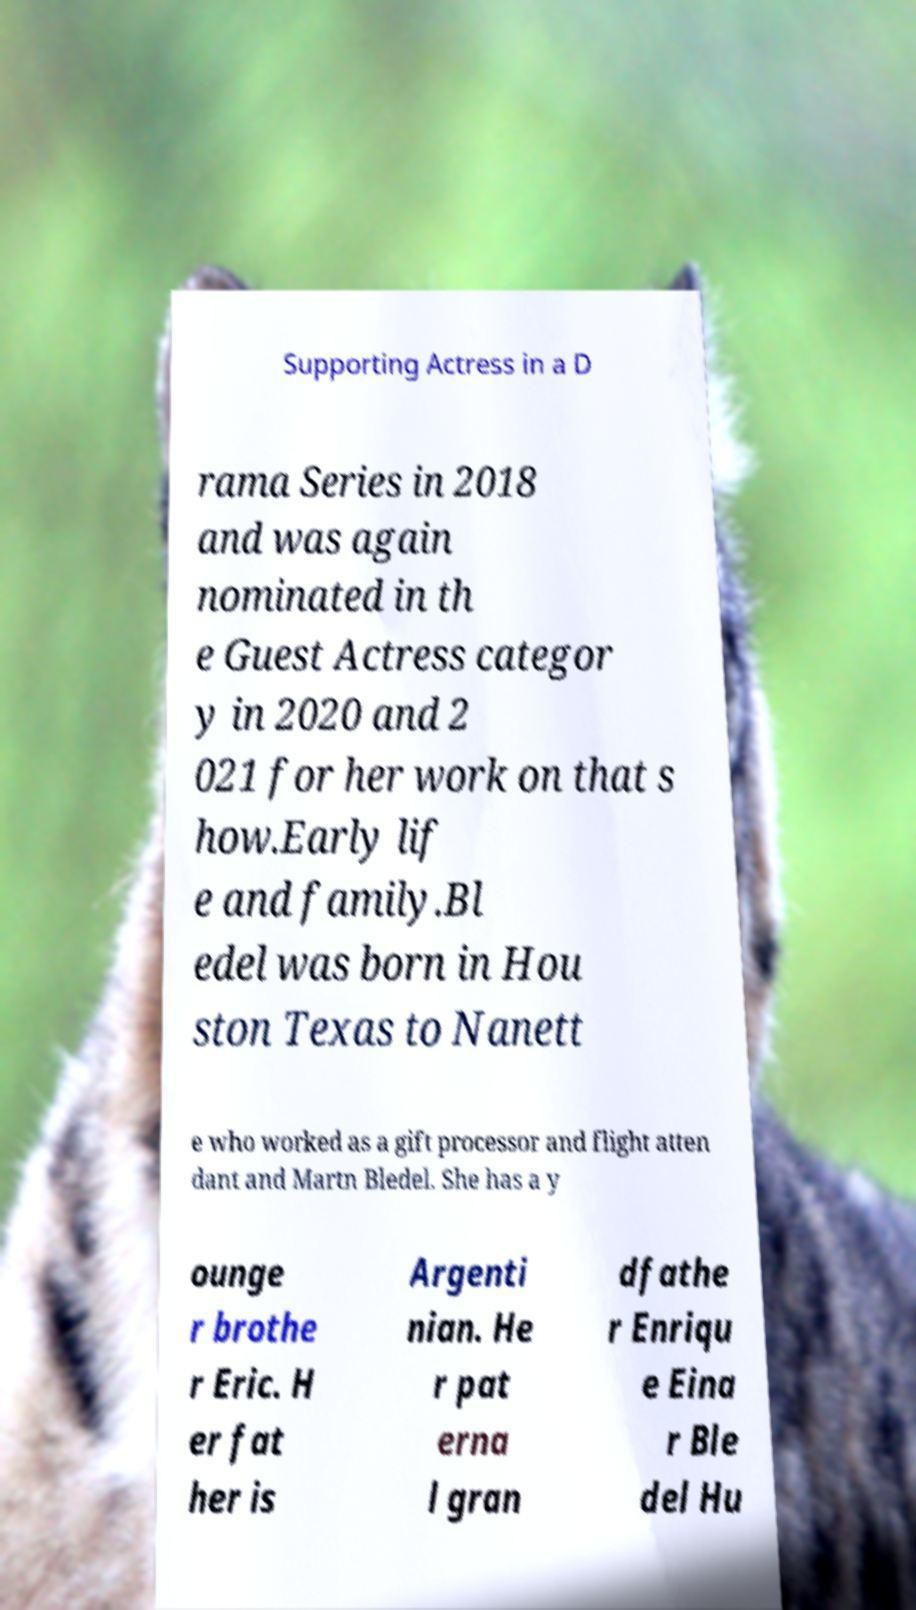Could you extract and type out the text from this image? Supporting Actress in a D rama Series in 2018 and was again nominated in th e Guest Actress categor y in 2020 and 2 021 for her work on that s how.Early lif e and family.Bl edel was born in Hou ston Texas to Nanett e who worked as a gift processor and flight atten dant and Martn Bledel. She has a y ounge r brothe r Eric. H er fat her is Argenti nian. He r pat erna l gran dfathe r Enriqu e Eina r Ble del Hu 